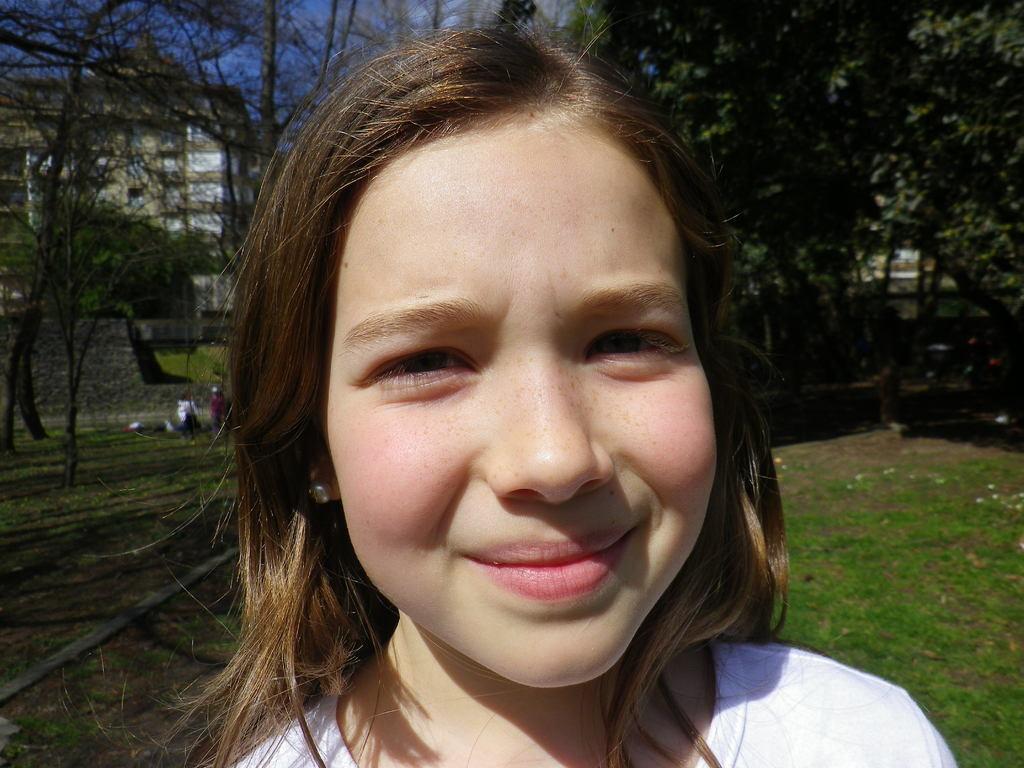Describe this image in one or two sentences. In front of the picture there is a girl, behind her at the bottom there is grass. In the background there are trees, building, wall and people. Sky is sunny. 